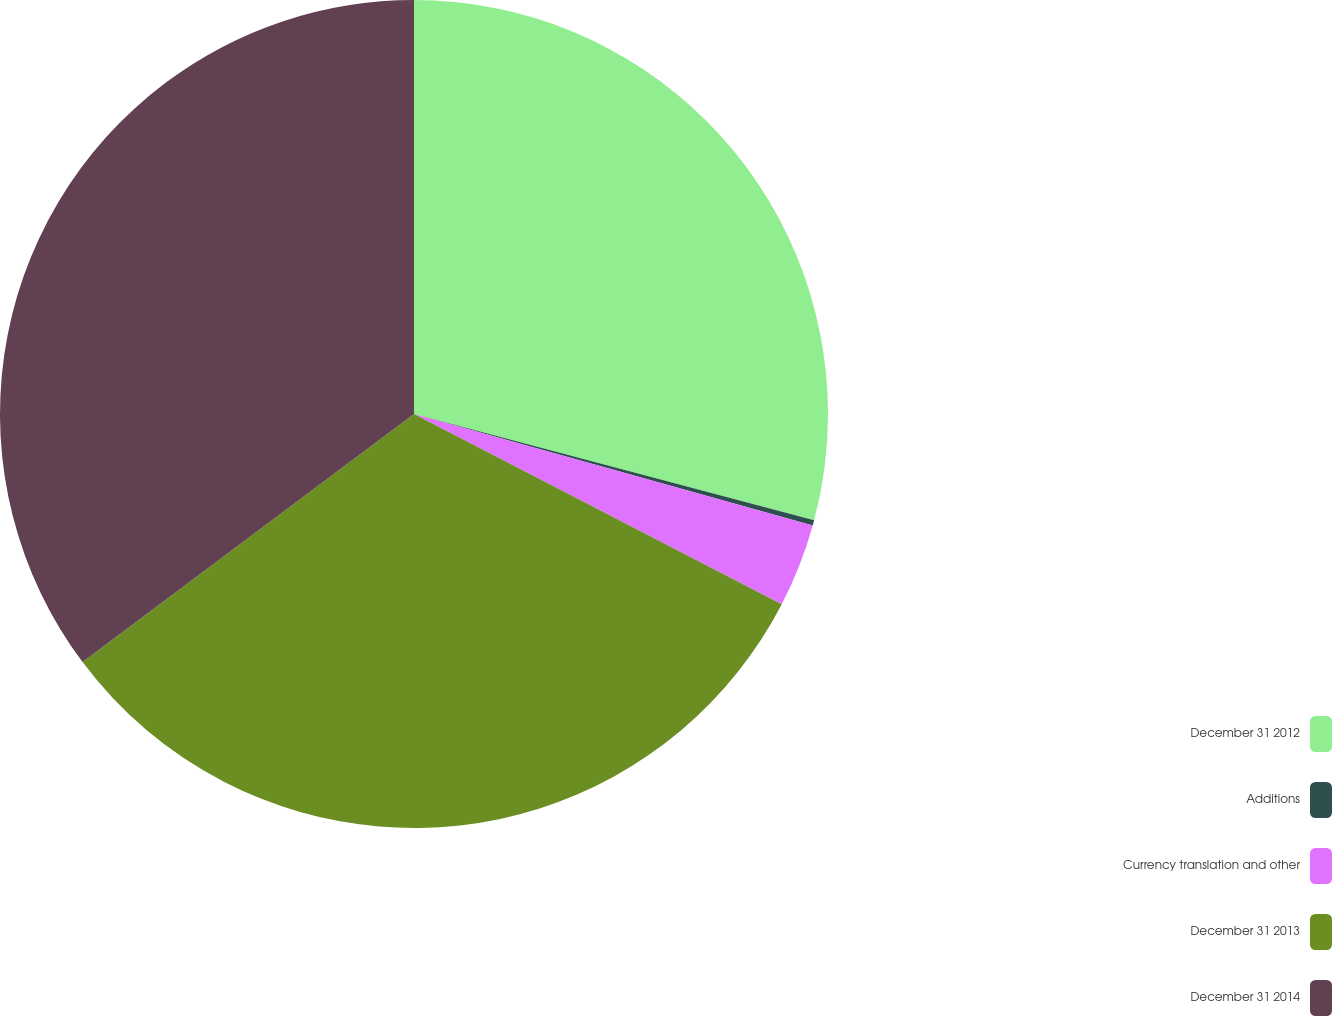Convert chart. <chart><loc_0><loc_0><loc_500><loc_500><pie_chart><fcel>December 31 2012<fcel>Additions<fcel>Currency translation and other<fcel>December 31 2013<fcel>December 31 2014<nl><fcel>29.13%<fcel>0.21%<fcel>3.26%<fcel>32.18%<fcel>35.23%<nl></chart> 